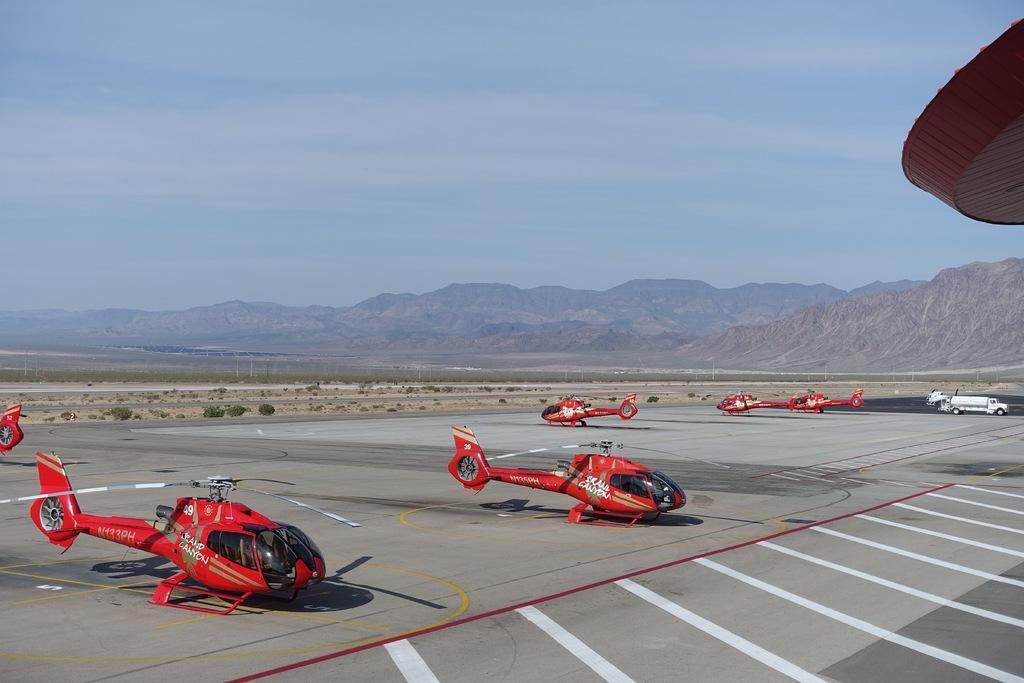In one or two sentences, can you explain what this image depicts? In this image I can see few aircraft's and they are in red color, background I can see few plants in green color, mountains and the sky is in blue color. 